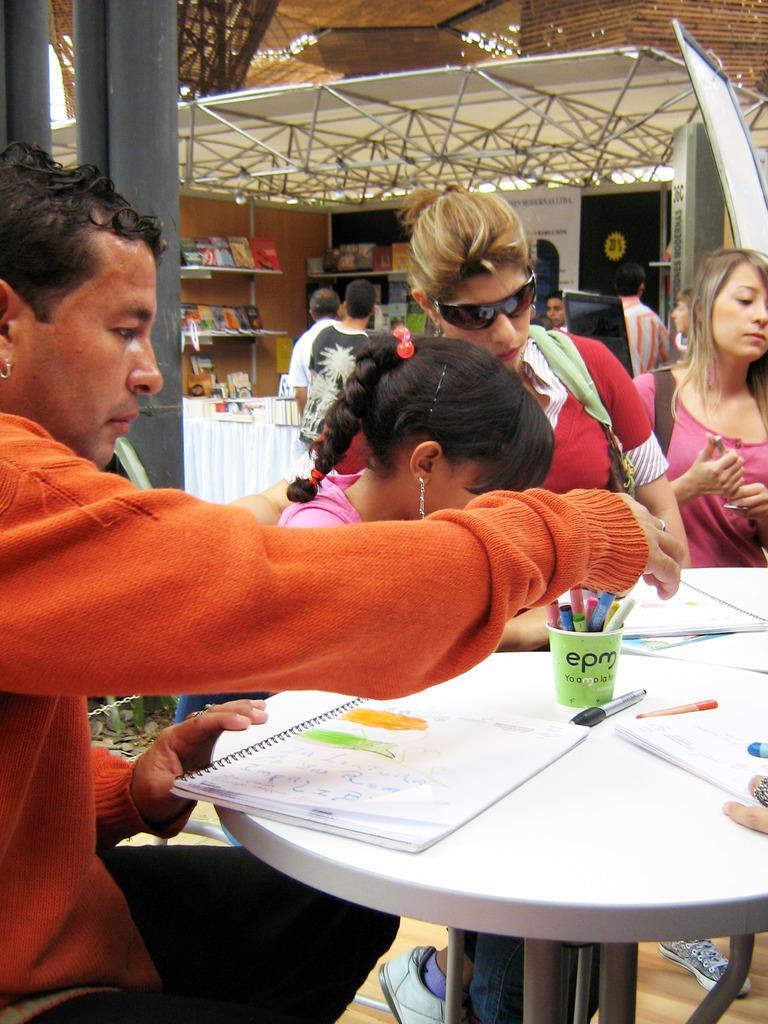How would you summarize this image in a sentence or two? This is the picture of some people who are sitting around the table on which there are some papers and some crayons and behind there is a shed in which there are some shelves on which some books and things are placed. 